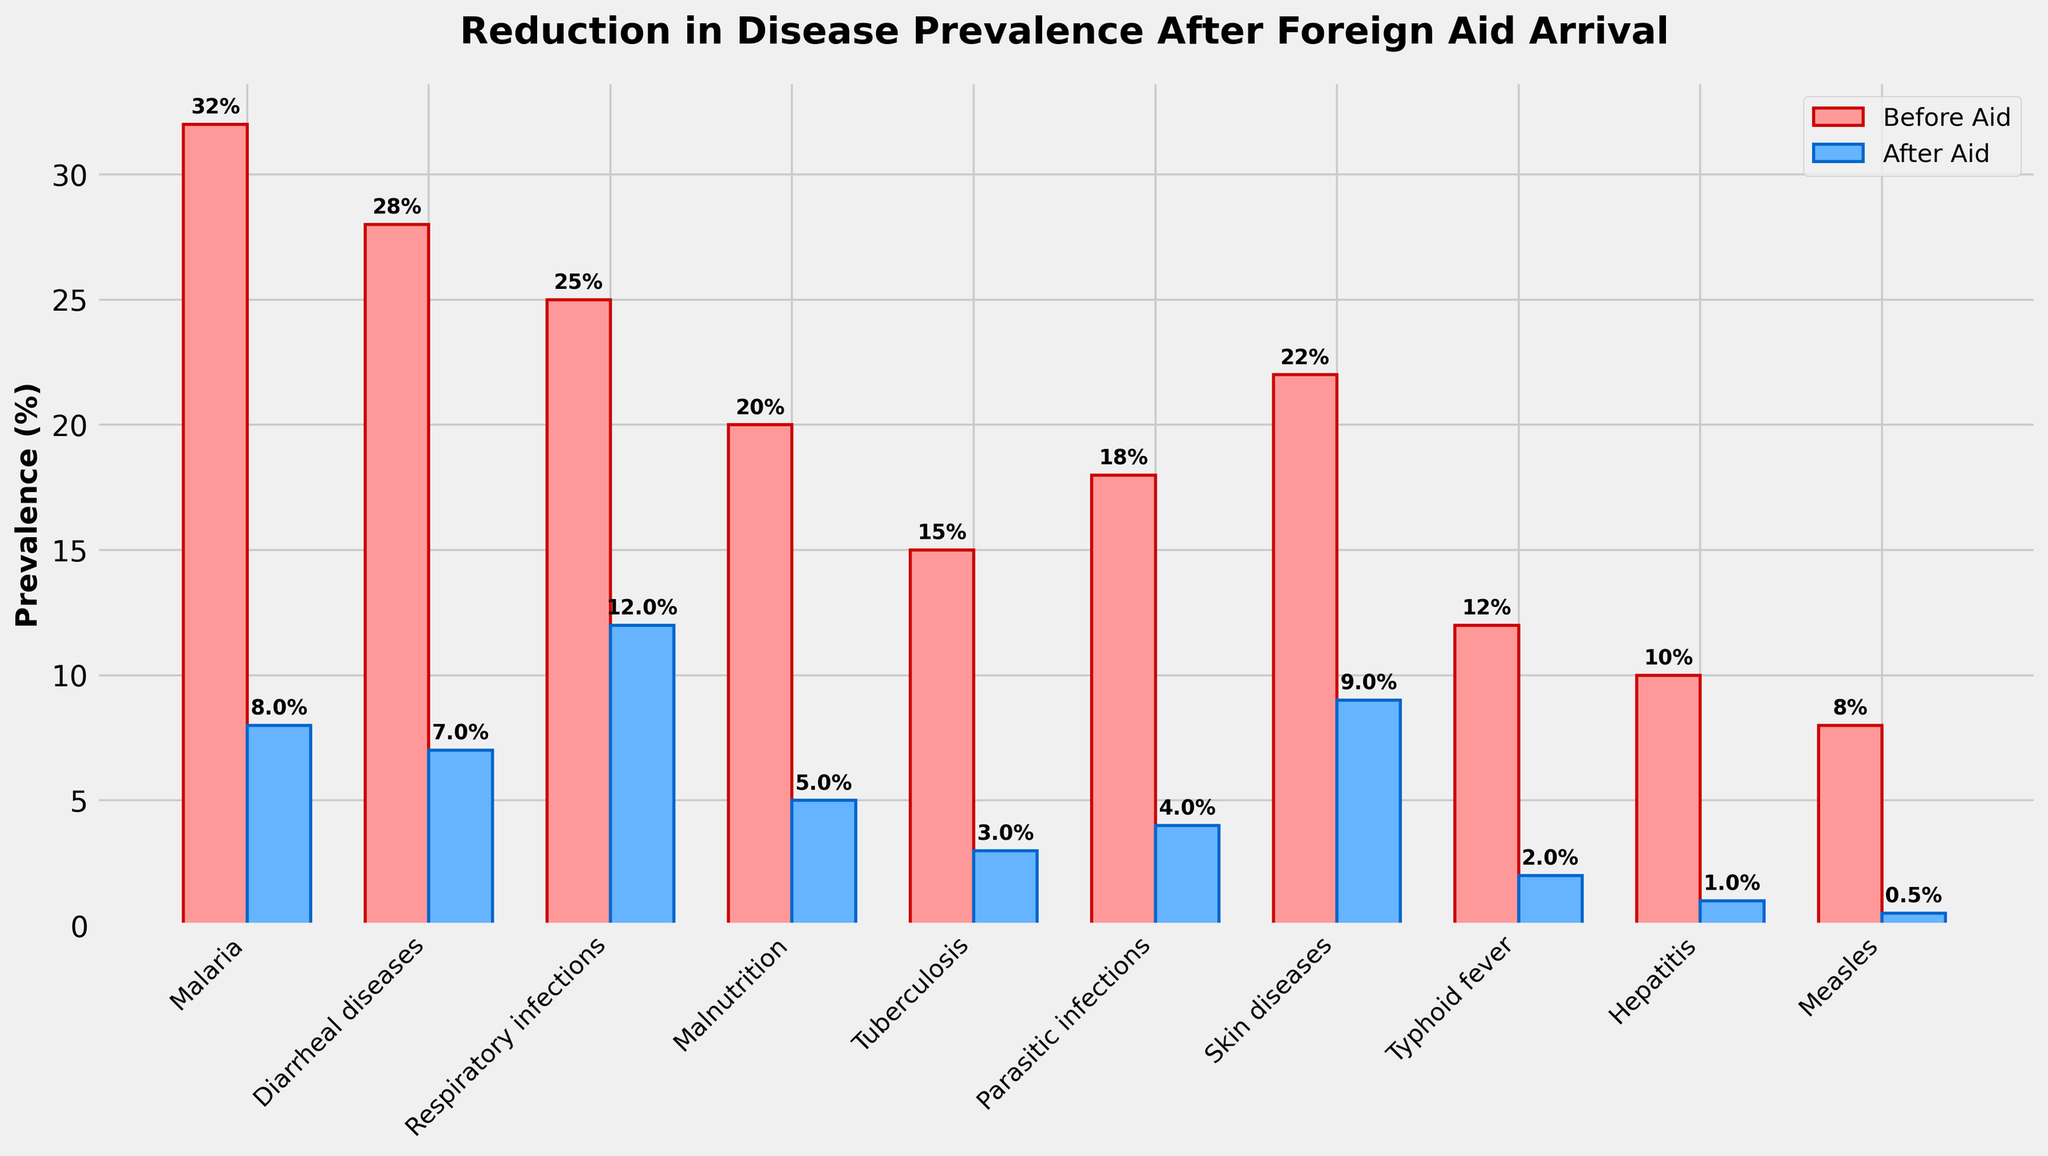Which disease had the highest prevalence before the aid arrived? To find the disease with the highest prevalence before the aid arrived, look at the heights of the bars colored in red for the 'Before Aid' group. The highest bar corresponds to Malaria.
Answer: Malaria Which disease showed the greatest reduction in prevalence after the aid arrived? Calculate the difference in prevalence for each disease by subtracting the 'After Aid' percentage from the 'Before Aid' percentage. The disease with the largest difference is Malaria (32% - 8% = 24%).
Answer: Malaria How much did the prevalence of Typhoid Fever decrease after the aid arrived? Look for the bars corresponding to Typhoid Fever. The prevalence before the aid was 12% and after the aid was 2%. The decrease is 12% - 2% = 10%.
Answer: 10% Among Malnutrition, Parasitic infections, and Tuberculosis, which had the smallest reduction in prevalence? Calculate the reductions for each: Malnutrition (20% - 5% = 15%), Parasitic infections (18% - 4% = 14%), and Tuberculosis (15% - 3% = 12%). The smallest reduction is for Tuberculosis.
Answer: Tuberculosis What is the total prevalence of all diseases combined after the aid arrived? Sum up the 'After Aid' percentages for all diseases: 8% + 7% + 12% + 5% + 3% + 4% + 9% + 2% + 1% + 0.5% = 51.5%.
Answer: 51.5% Which disease has the smallest difference in prevalence between before and after the aid? Determine the difference between 'Before Aid' and 'After Aid' for each disease and find the smallest one. For Measles, the difference is 7.5% (8% - 0.5%), which is the smallest among all.
Answer: Measles Which disease had a prevalence under 5% both before and after receiving aid? Check the 'Before Aid' and 'After Aid' percentages for each disease and see which ones are under 5%. Only Hepatitis (10% to 1%) had 'After Aid' prevalence under 5%, but no diseases were under 5% both times.
Answer: None What percentage reduction did Respiratory infections face after the aid arrived? Identify the percentage of Respiratory infections before (25%) and after (12%) the aid. Calculate the reduction: 25% - 12% = 13%.
Answer: 13% Which two diseases had equal prevalence after the aid arrived? Identify the diseases with the same 'After Aid' percentage. There are none with equal post-aid prevalence based on the data provided.
Answer: None What was the average prevalence of Malaria, Diarrheal diseases, and Respiratory infections after the aid arrived? Add the 'After Aid' percentages of these diseases: 8% + 7% + 12% = 27%. Divide the total by 3 to get the average: 27% / 3 = 9%.
Answer: 9% 